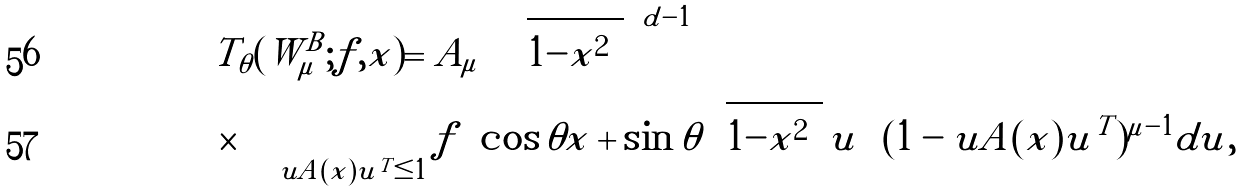Convert formula to latex. <formula><loc_0><loc_0><loc_500><loc_500>& T _ { \theta } ( W _ { \mu } ^ { B } ; f , x ) = A _ { \mu } \left ( \sqrt { 1 - \| x \| ^ { 2 } } \right ) ^ { d - 1 } \\ & \times \int _ { u A ( x ) u ^ { T } \leq 1 } f \left ( \cos \theta x + \sin \theta \sqrt { 1 - \| x \| ^ { 2 } } \, u \right ) ( 1 - u A ( x ) u ^ { T } ) ^ { \mu - 1 } d u ,</formula> 